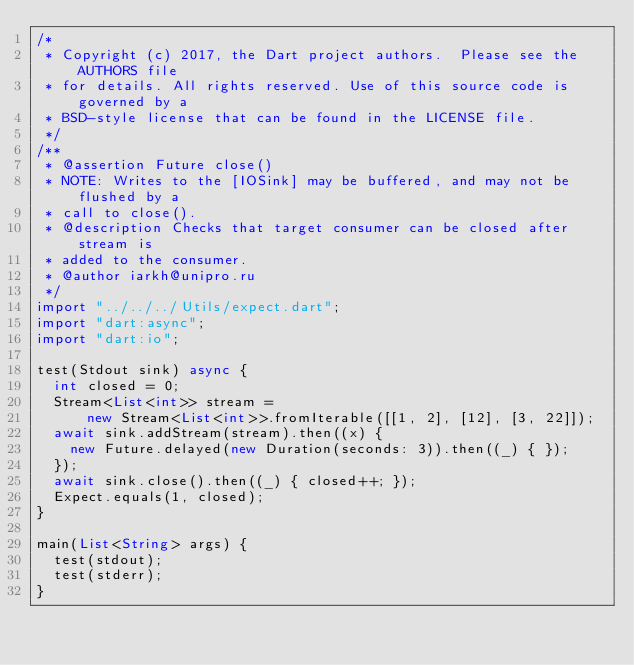<code> <loc_0><loc_0><loc_500><loc_500><_Dart_>/*
 * Copyright (c) 2017, the Dart project authors.  Please see the AUTHORS file
 * for details. All rights reserved. Use of this source code is governed by a
 * BSD-style license that can be found in the LICENSE file.
 */
/**
 * @assertion Future close()
 * NOTE: Writes to the [IOSink] may be buffered, and may not be flushed by a
 * call to close().
 * @description Checks that target consumer can be closed after stream is
 * added to the consumer.
 * @author iarkh@unipro.ru
 */
import "../../../Utils/expect.dart";
import "dart:async";
import "dart:io";

test(Stdout sink) async {
  int closed = 0;
  Stream<List<int>> stream =
      new Stream<List<int>>.fromIterable([[1, 2], [12], [3, 22]]);
  await sink.addStream(stream).then((x) {
    new Future.delayed(new Duration(seconds: 3)).then((_) { });
  });
  await sink.close().then((_) { closed++; });
  Expect.equals(1, closed);
}

main(List<String> args) {
  test(stdout);
  test(stderr);
}
</code> 